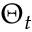Convert formula to latex. <formula><loc_0><loc_0><loc_500><loc_500>\Theta _ { t }</formula> 